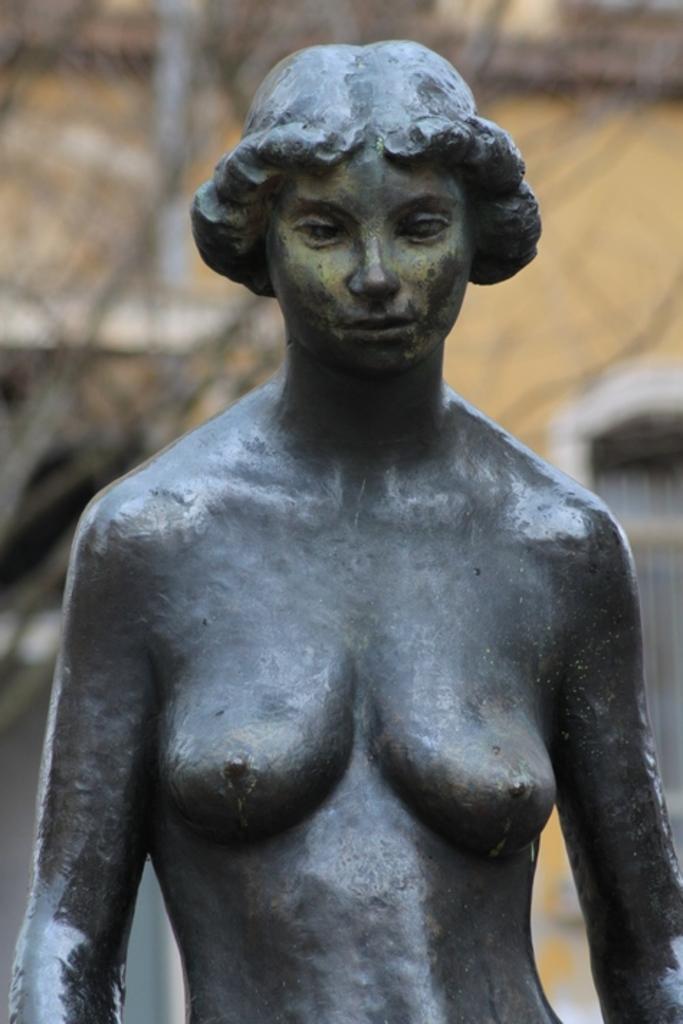Describe this image in one or two sentences. In the center of the image, we can see a sculpture and in the background, there is a building and we can see a window, on the right. 